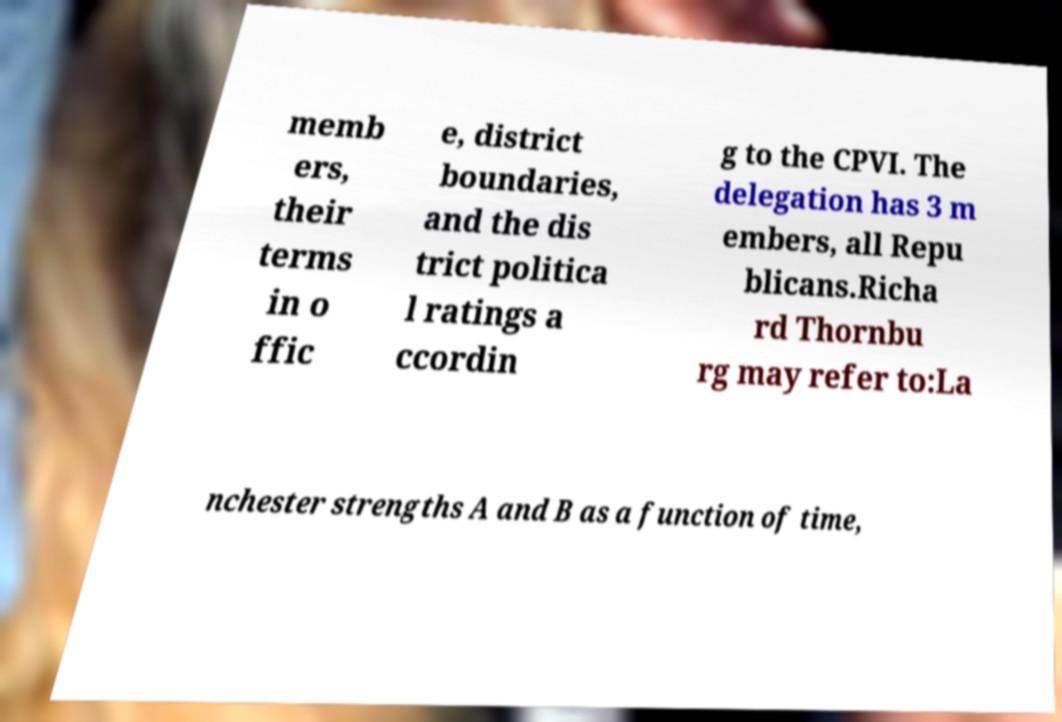What messages or text are displayed in this image? I need them in a readable, typed format. memb ers, their terms in o ffic e, district boundaries, and the dis trict politica l ratings a ccordin g to the CPVI. The delegation has 3 m embers, all Repu blicans.Richa rd Thornbu rg may refer to:La nchester strengths A and B as a function of time, 